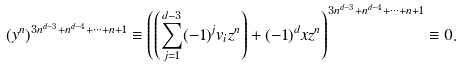<formula> <loc_0><loc_0><loc_500><loc_500>( y ^ { n } ) ^ { 3 n ^ { d - 3 } + n ^ { d - 4 } + \cdots + n + 1 } \equiv \left ( \left ( \sum _ { j = 1 } ^ { d - 3 } ( - 1 ) ^ { j } v _ { i } z ^ { n } \right ) + ( - 1 ) ^ { d } x z ^ { n } \right ) ^ { 3 n ^ { d - 3 } + n ^ { d - 4 } + \cdots + n + 1 } \equiv 0 .</formula> 